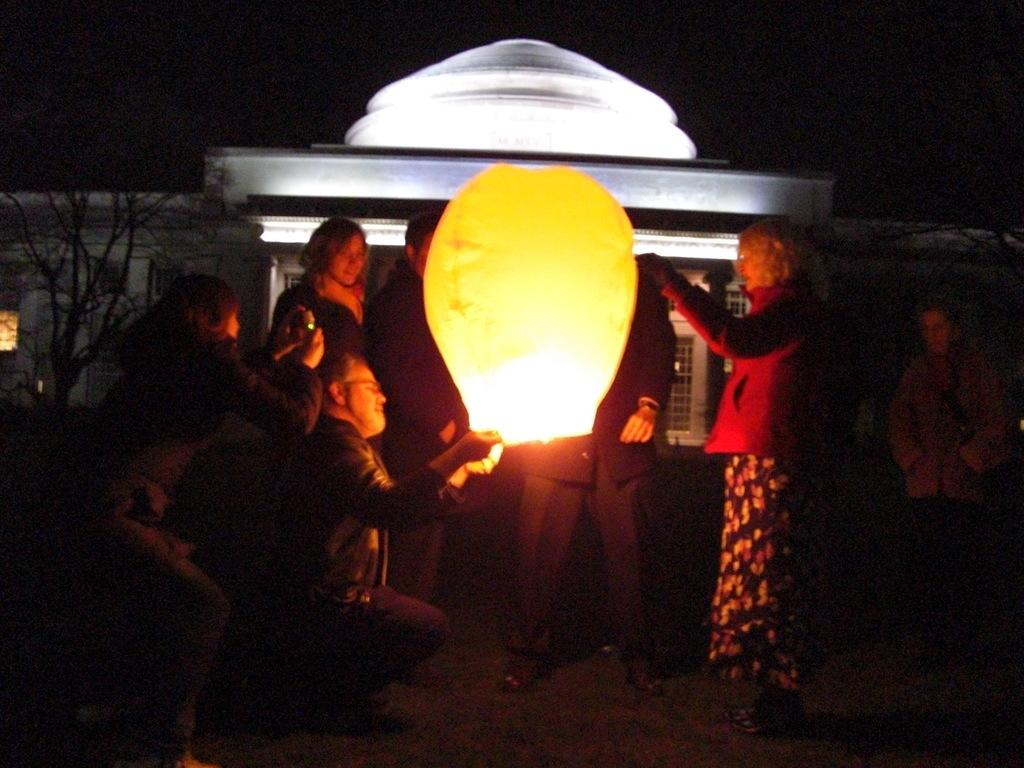What is happening in the image involving a group of people? There is a group of people in the image, and they are standing. What are the people holding in the image? The people are holding lights. What can be seen in the background of the image? There are houses and trees in the background of the image. What type of poison is being used by the people in the image? There is no poison present in the image; the people are holding lights. What is the sister of the person holding the light doing in the image? The facts provided do not mention a sister or any other individuals besides the group of people holding lights. 